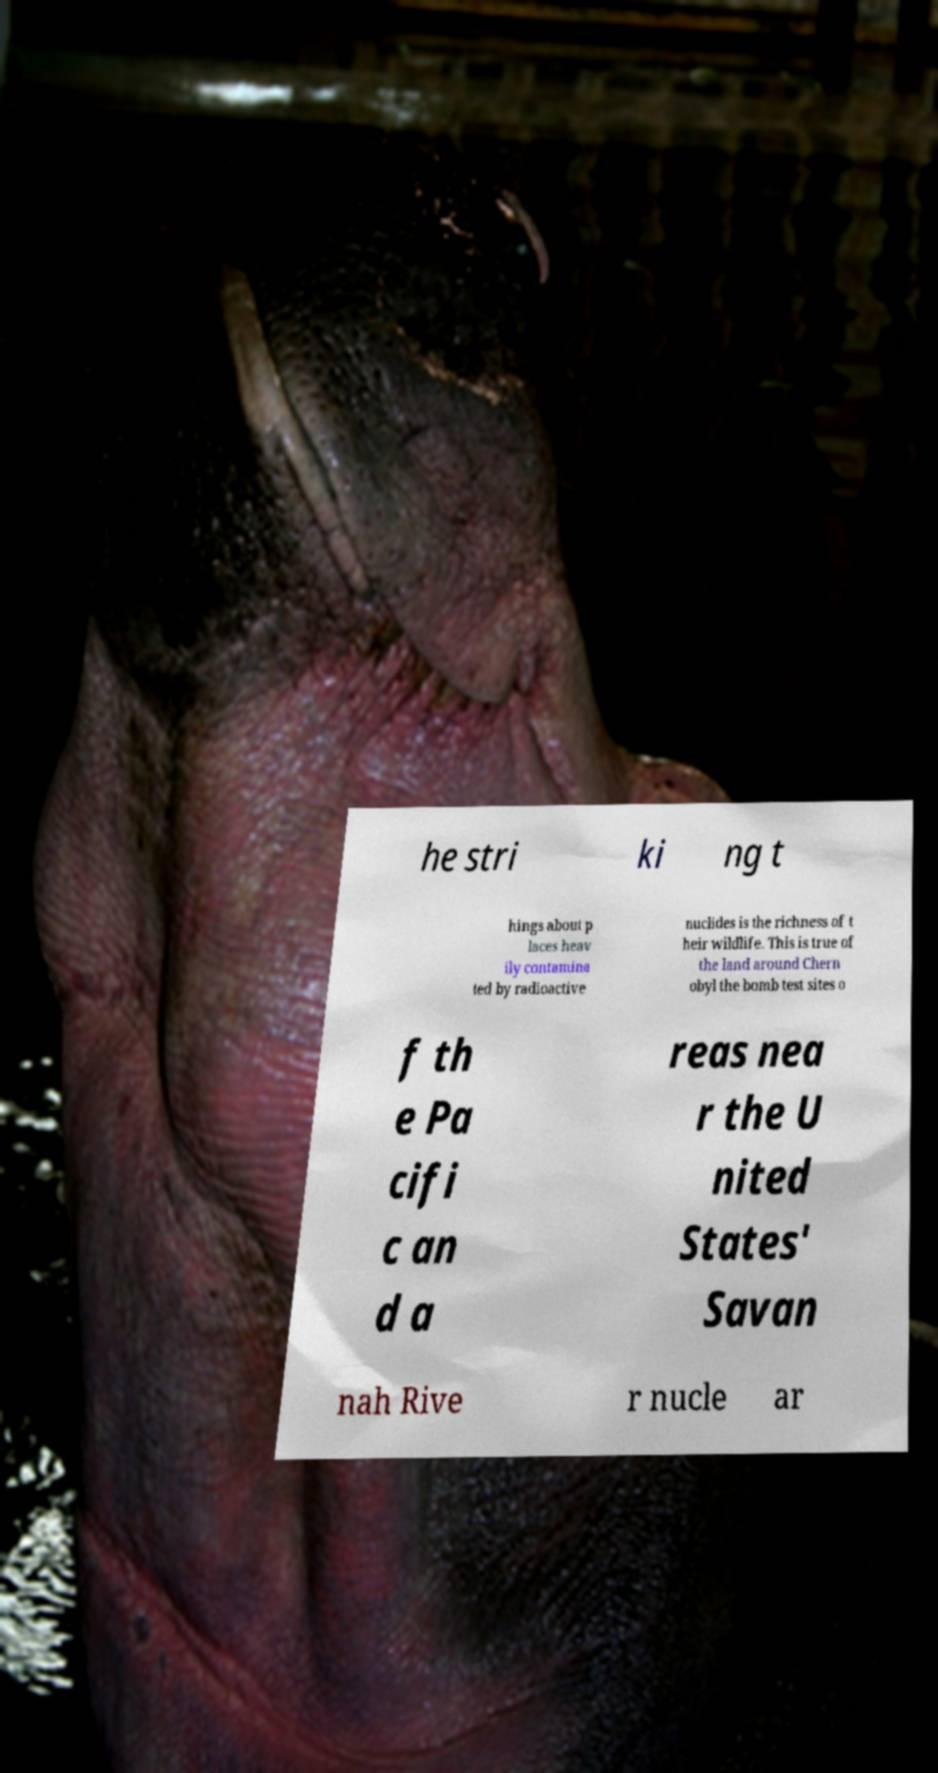Could you extract and type out the text from this image? he stri ki ng t hings about p laces heav ily contamina ted by radioactive nuclides is the richness of t heir wildlife. This is true of the land around Chern obyl the bomb test sites o f th e Pa cifi c an d a reas nea r the U nited States' Savan nah Rive r nucle ar 